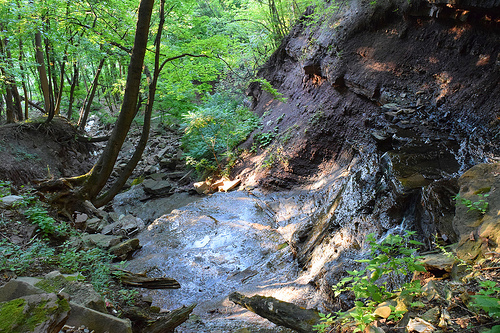<image>
Is the tree above the pond? Yes. The tree is positioned above the pond in the vertical space, higher up in the scene. 